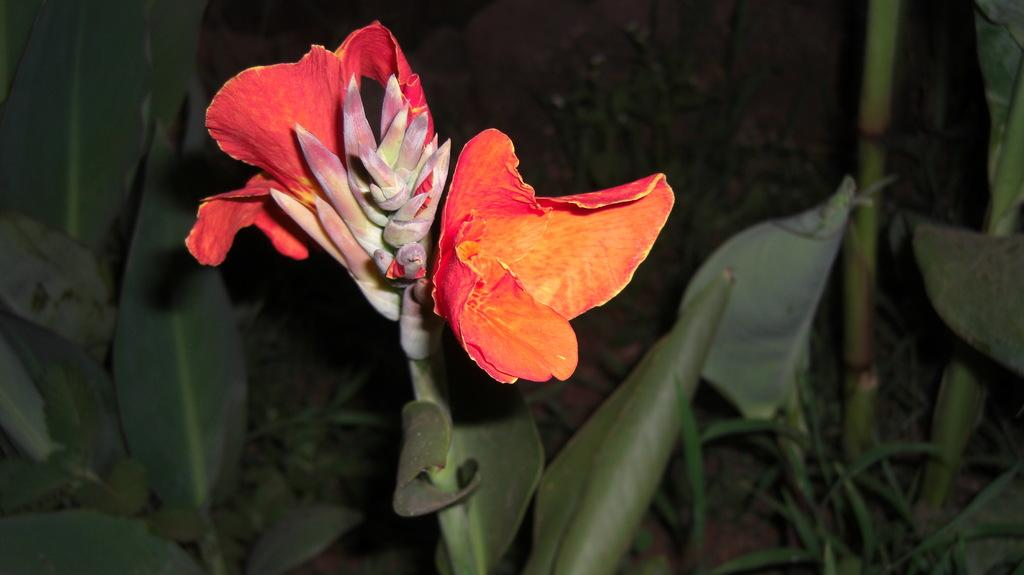What color are the flowers on the plant in the image? The flowers on the plant are red. What stage of growth are some of the flowers in? There are buds on the plant, indicating that some flowers are not yet fully bloomed. What can be seen in the background of the image? There are many plants in the background. How many trucks are parked next to the plants in the image? There are no trucks present in the image; it only features plants and flowers. What type of nut can be seen growing on the plant in the image? There is no nut visible on the plant in the image; it only has flowers and buds. 